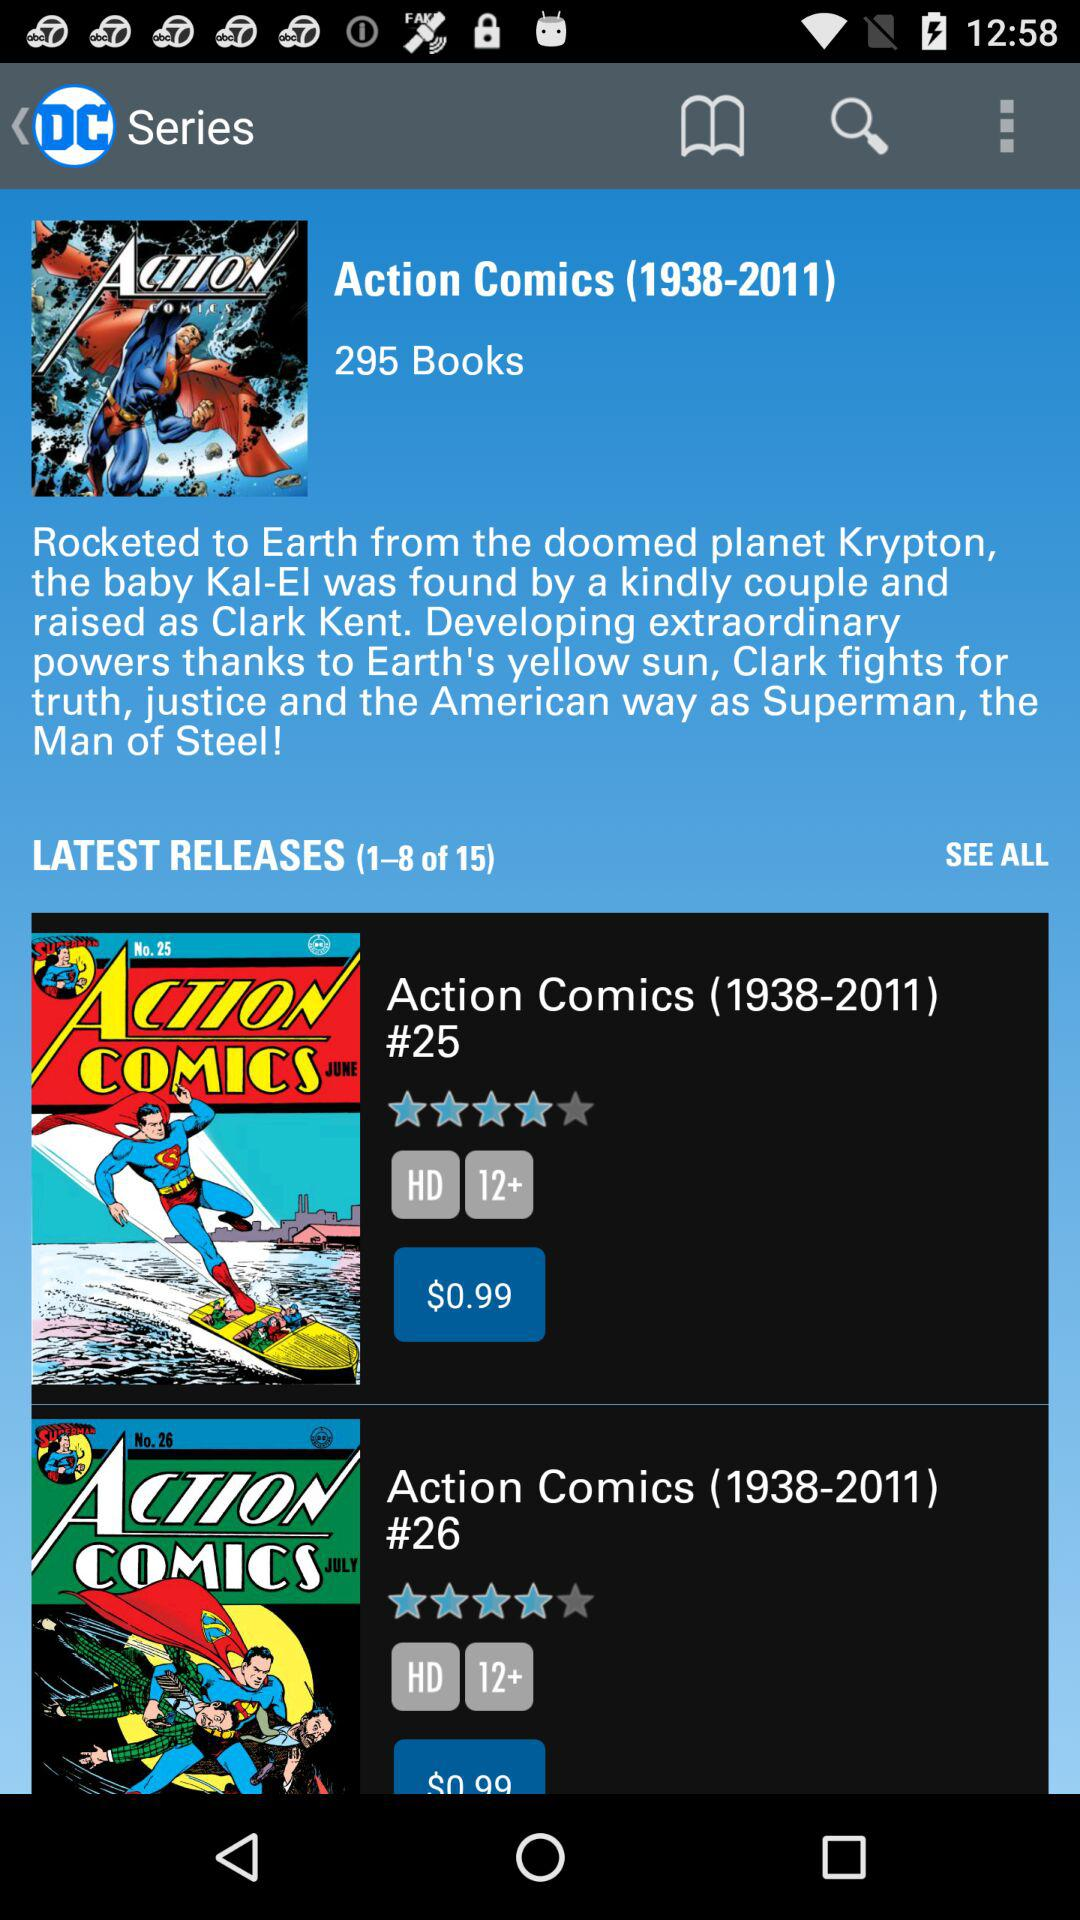How many books are in the latest releases? There are 15 books. 